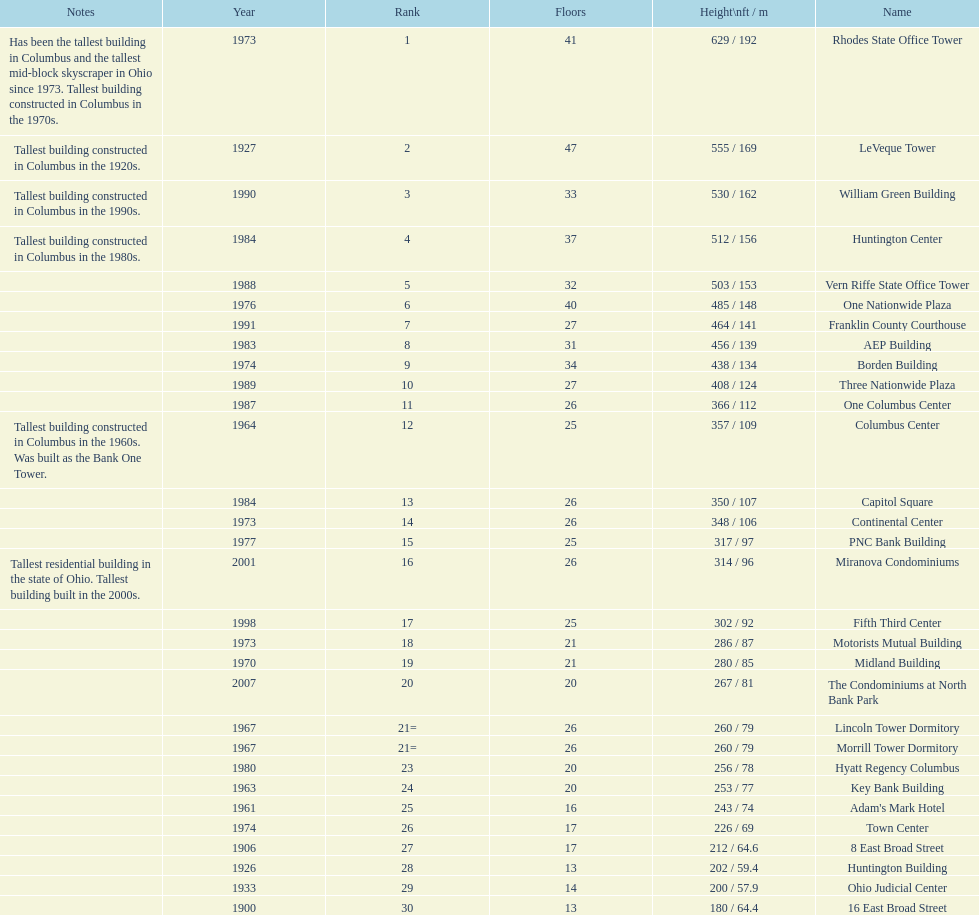What number of floors does the leveque tower have? 47. 